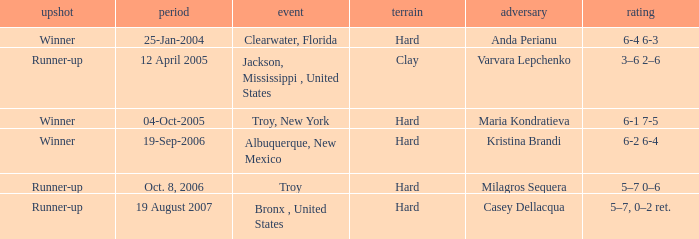Where was the tournament played on Oct. 8, 2006? Troy. 